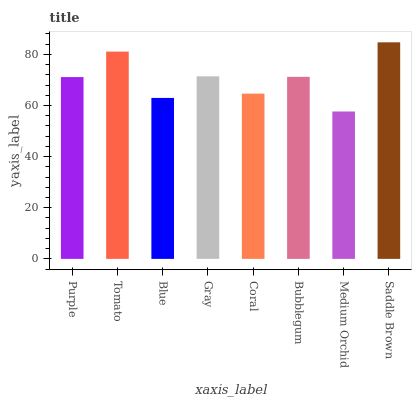Is Medium Orchid the minimum?
Answer yes or no. Yes. Is Saddle Brown the maximum?
Answer yes or no. Yes. Is Tomato the minimum?
Answer yes or no. No. Is Tomato the maximum?
Answer yes or no. No. Is Tomato greater than Purple?
Answer yes or no. Yes. Is Purple less than Tomato?
Answer yes or no. Yes. Is Purple greater than Tomato?
Answer yes or no. No. Is Tomato less than Purple?
Answer yes or no. No. Is Bubblegum the high median?
Answer yes or no. Yes. Is Purple the low median?
Answer yes or no. Yes. Is Blue the high median?
Answer yes or no. No. Is Tomato the low median?
Answer yes or no. No. 